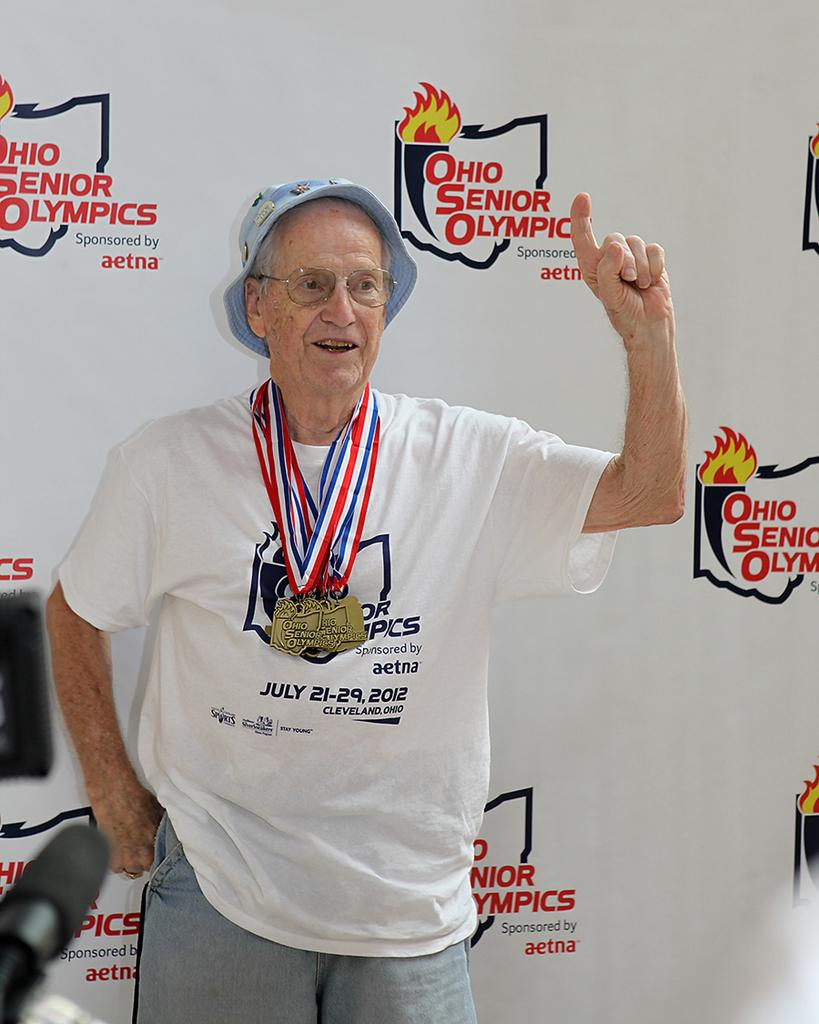<image>
Create a compact narrative representing the image presented. Man standing in front of a sign that says Ohio Senior Olympics. 